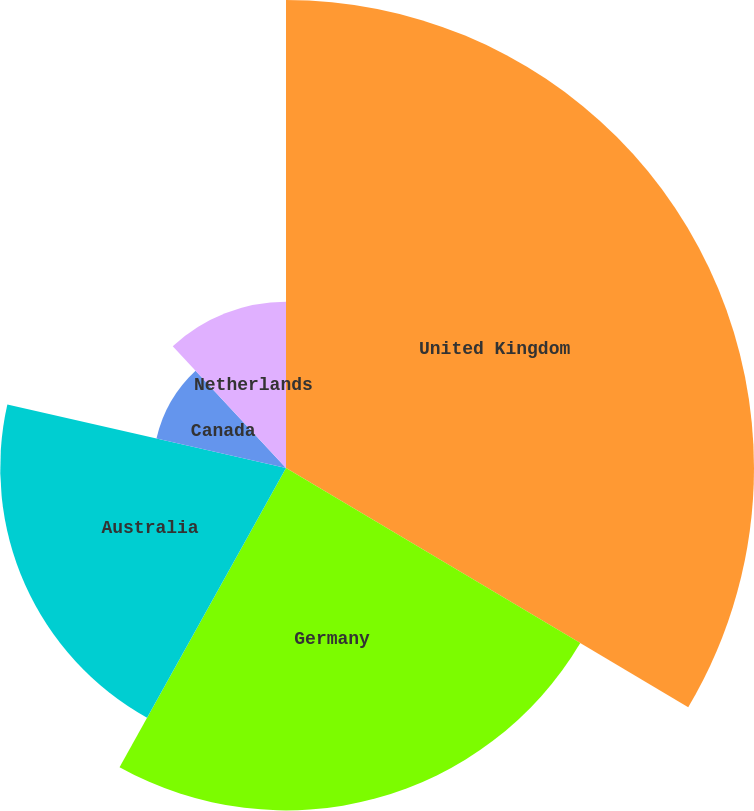Convert chart. <chart><loc_0><loc_0><loc_500><loc_500><pie_chart><fcel>United Kingdom<fcel>Germany<fcel>Australia<fcel>Canada<fcel>Netherlands<nl><fcel>33.54%<fcel>24.54%<fcel>20.48%<fcel>9.52%<fcel>11.92%<nl></chart> 